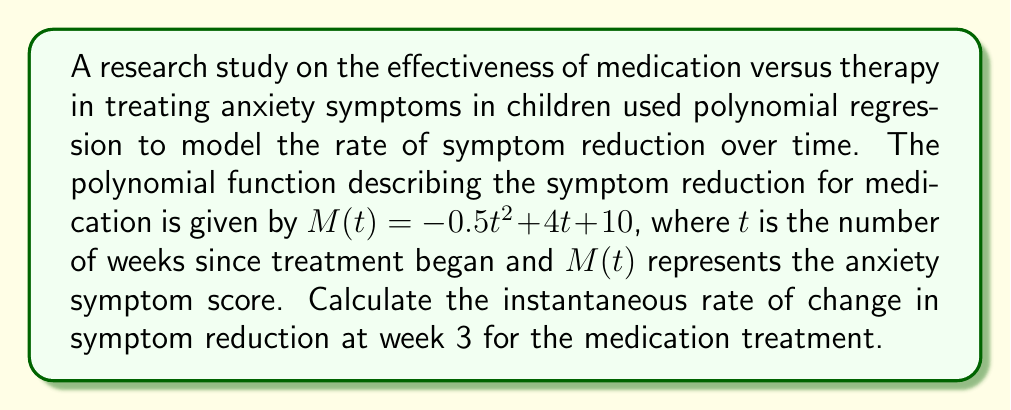Provide a solution to this math problem. To find the instantaneous rate of change at a specific point, we need to calculate the derivative of the function and evaluate it at the given point. Here's how we can do this step-by-step:

1) The given polynomial function is:
   $M(t) = -0.5t^2 + 4t + 10$

2) To find the rate of change, we need to calculate the first derivative of $M(t)$:
   $M'(t) = \frac{d}{dt}(-0.5t^2 + 4t + 10)$
   $M'(t) = -0.5 \cdot 2t + 4$
   $M'(t) = -t + 4$

3) The instantaneous rate of change at week 3 is found by evaluating $M'(t)$ at $t=3$:
   $M'(3) = -(3) + 4 = -3 + 4 = 1$

The positive value indicates that the symptom score is still increasing at week 3, but at a slower rate than initially. This could be interpreted as the medication starting to take effect, gradually reducing the rate at which anxiety symptoms are experienced.
Answer: The instantaneous rate of change in symptom reduction at week 3 for the medication treatment is $1$ unit per week. 